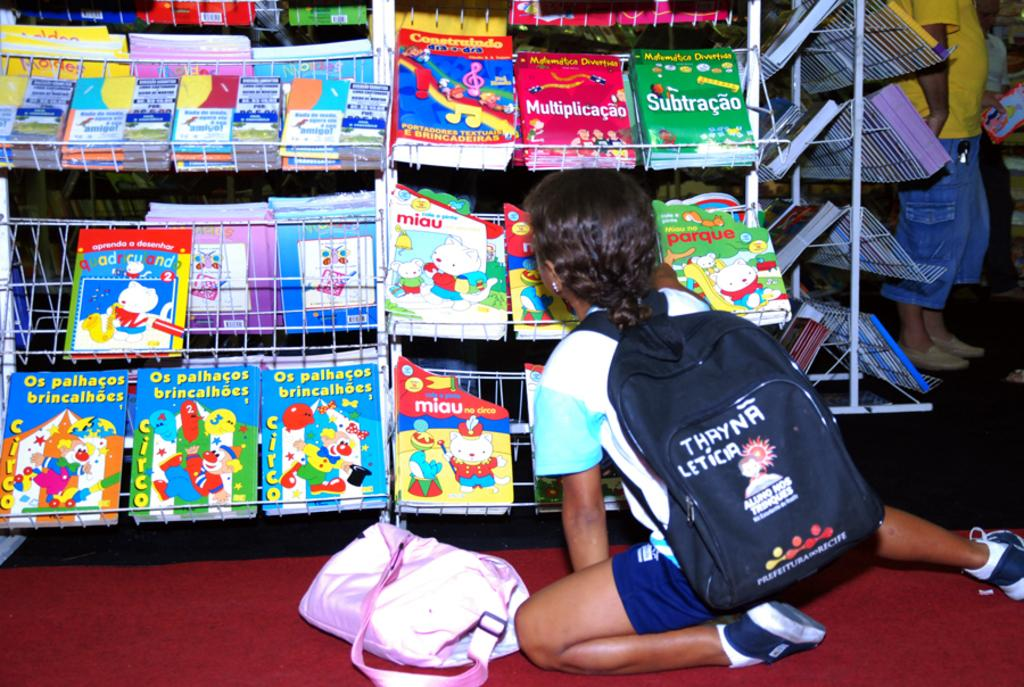Provide a one-sentence caption for the provided image. Little kid is sitting on the floor looking at different books. 